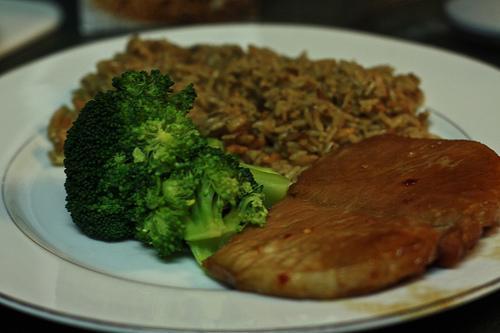How many plates are there?
Give a very brief answer. 1. How many veggies are there?
Give a very brief answer. 1. How many different types of food are on the plate?
Give a very brief answer. 3. How many vegetables are on the plate?
Give a very brief answer. 1. How many people appear in this photo?
Give a very brief answer. 0. 